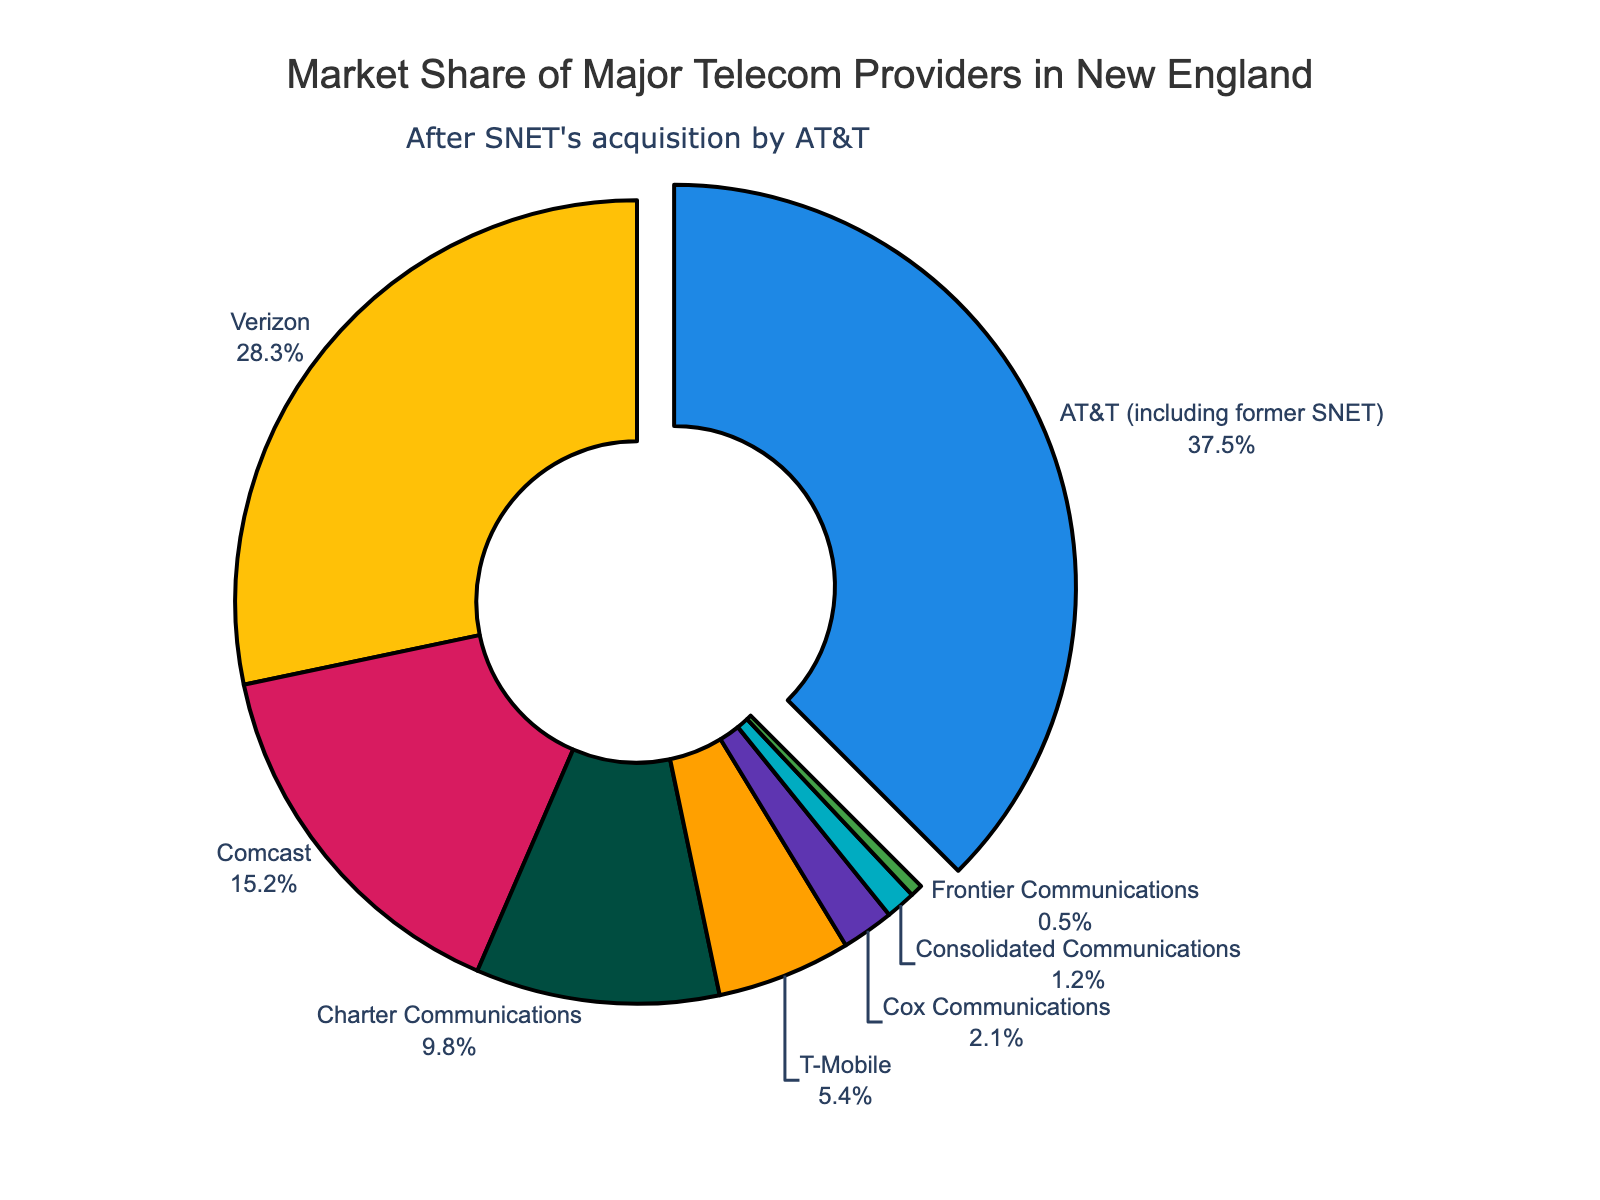Which provider has the largest market share? The largest segment of the pie chart has the label "AT&T (including former SNET)" and occupies a substantial percentage of the chart. This indicates that AT&T has the largest market share among the telecom providers in New England.
Answer: AT&T (including former SNET) Which providers have a combined market share greater than 50%? By examining the pie chart, AT&T has 37.5% and Verizon has 28.3%. Summing their shares: 37.5% + 28.3% = 65.8%, which is greater than 50%. No further providers need to be considered as these two alone exceed 50%.
Answer: AT&T (including former SNET) and Verizon What is the combined market share of Charter Communications and T-Mobile? From the pie chart, Charter Communications has a market share of 9.8% and T-Mobile has a market share of 5.4%. Adding these together: 9.8% + 5.4% = 15.2%.
Answer: 15.2% Which provider has the smallest market share? The smallest segment of the pie chart is labeled "Frontier Communications" and has the smallest percentage. This indicates that Frontier Communications has the smallest market share among the listed providers.
Answer: Frontier Communications How much larger is AT&T's market share compared to Comcast's? From the pie chart, AT&T's market share is 37.5% and Comcast's is 15.2%. Calculating the difference: 37.5% - 15.2% = 22.3%.
Answer: 22.3% If we combine the market shares of Cox Communications, Consolidated Communications, and Frontier Communications, what is the total? The pie chart shows Cox Communications with 2.1%, Consolidated Communications with 1.2%, and Frontier Communications with 0.5%. Adding these together: 2.1% + 1.2% + 0.5% = 3.8%.
Answer: 3.8% Which two providers have a combined market share closest to 10%? From the pie chart, Charter Communications has 9.8% and adding the next smallest share (Frontier Communications, 0.5%) exceeds 10%, so consider individual shares close to 5%: T-Mobile (5.4%) and Cox Communications (2.1%) or Consolidated Communications (1.2%) both exceed but not quite 10%. However, Charter Communications independently is very close to 10%.
Answer: Charter Communications 